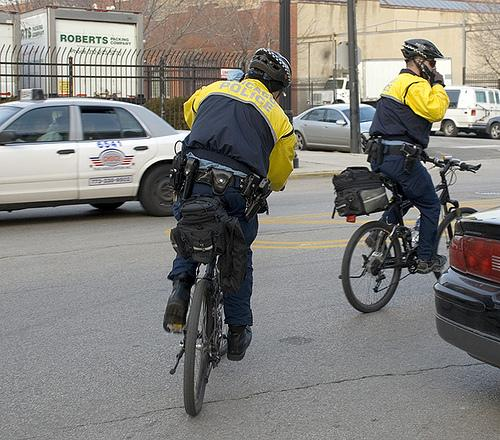Identify and describe three different types of vehicles in this image. 1. A white car in the background. 2. A black car parked by the curb. 3. Two bicycles ridden by police officers. Describe the attire of the police officer who is riding a bike. The police officer is wearing a black and white helmet, a yellow and blue jacket, and has a utility belt on his waist. Please describe the clothing worn by one of the men riding bicycles. One man is wearing a black and yellow jacket, black pants, and black boots. Find the tree between the white car and the grey car. There is no tree between the white car and the grey car in the image. 